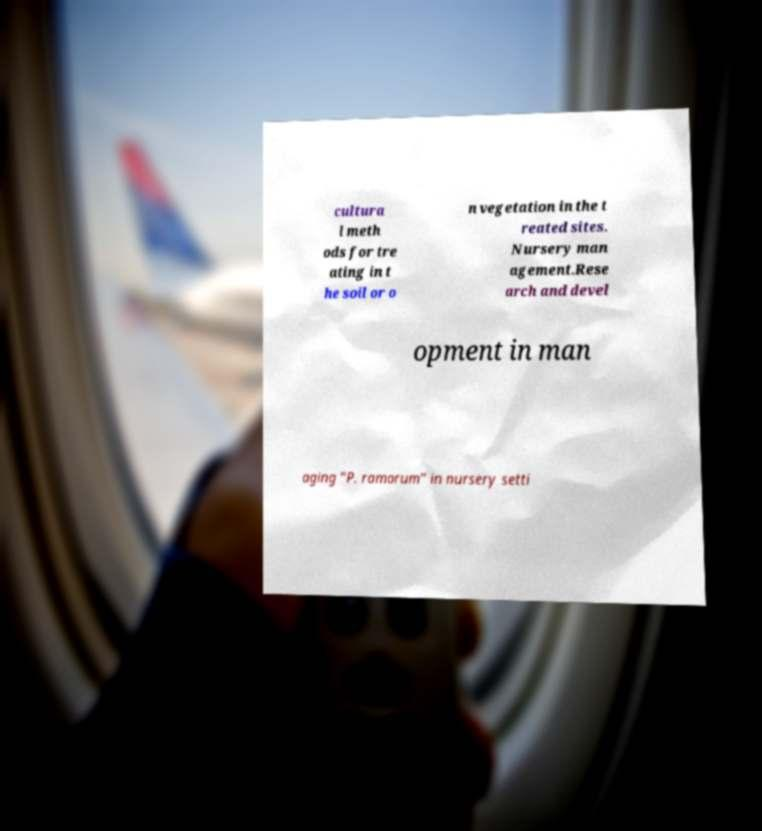Could you extract and type out the text from this image? cultura l meth ods for tre ating in t he soil or o n vegetation in the t reated sites. Nursery man agement.Rese arch and devel opment in man aging "P. ramorum" in nursery setti 